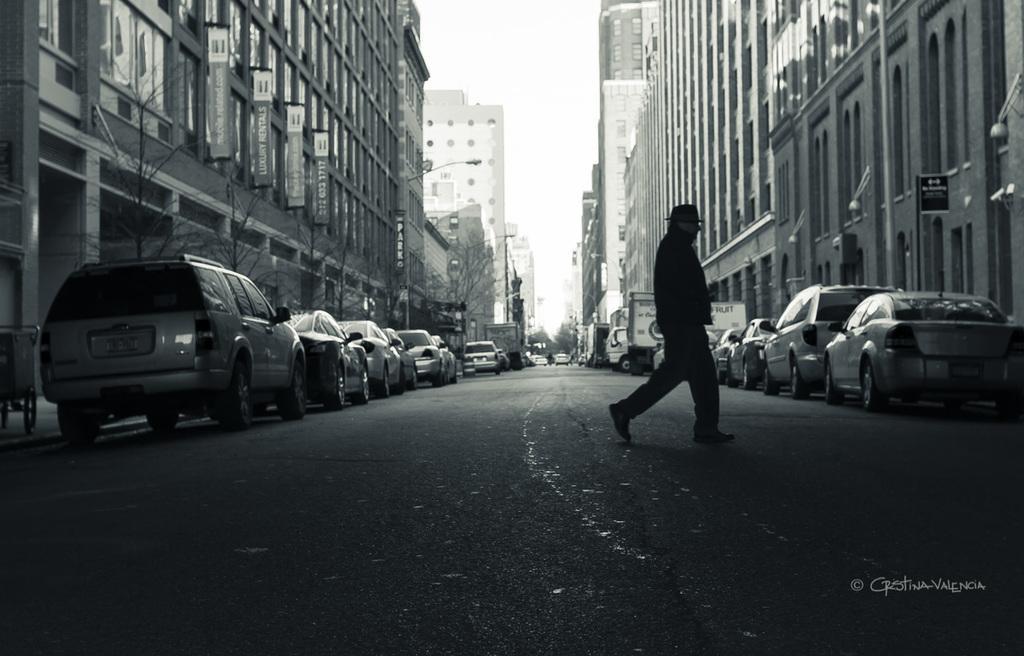Describe this image in one or two sentences. In the center of the image there is a person walking on the road. On the right side of the image we can see cars and buildings. On the left side of the image we can see trees, cars and buildings. In the background there is a sky. 